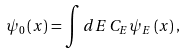<formula> <loc_0><loc_0><loc_500><loc_500>\psi _ { 0 } \left ( x \right ) = \int d E \, C _ { E } \psi _ { E } \left ( x \right ) ,</formula> 